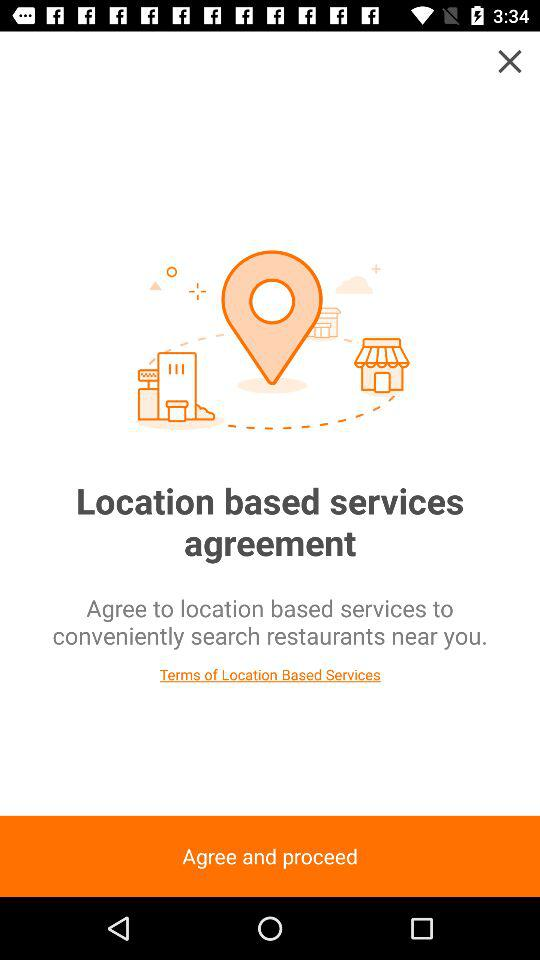What is the application name? The application name is "MANGOPLATE". 